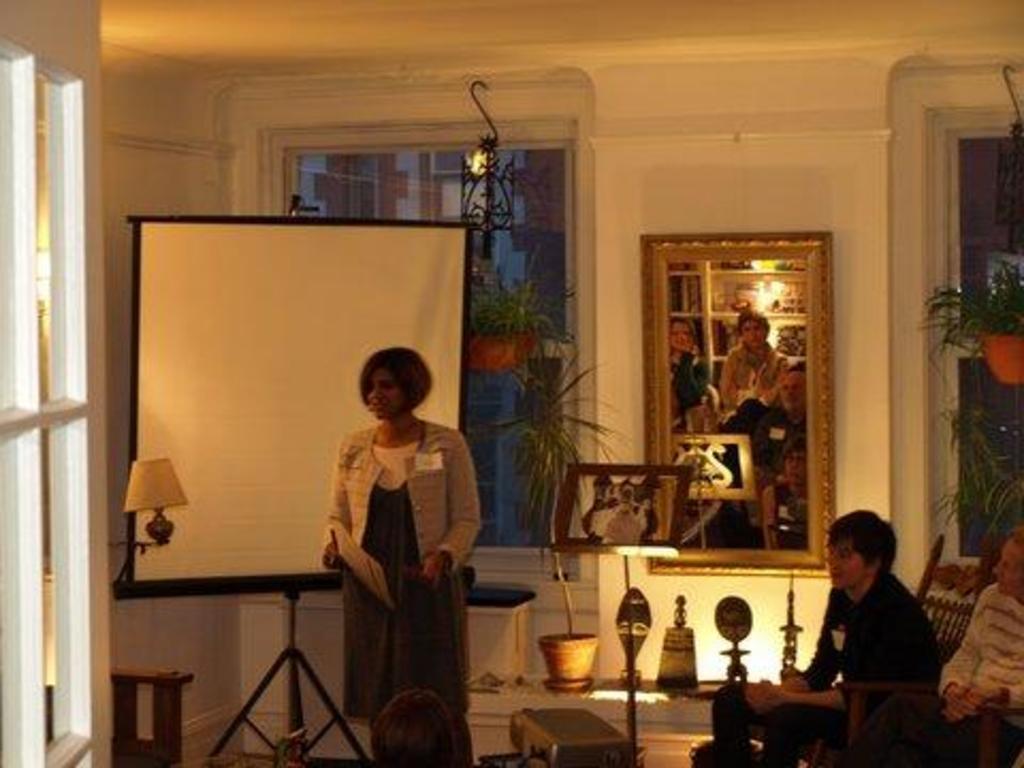Please provide a concise description of this image. This is an inside view. Here I can see a woman standing and looking at the left side. On the right side two men are sitting and looking at this woman. At the bottom, I can see a person's head. At the back of her there is a board. In the background there are few plants and also few metal objects placed on the floor. On the left side there is a window. In the background there is a mirror attached to the wall. In the mirror, I can see the reflection of two persons who are sitting. Beside the mirror there is a window. 